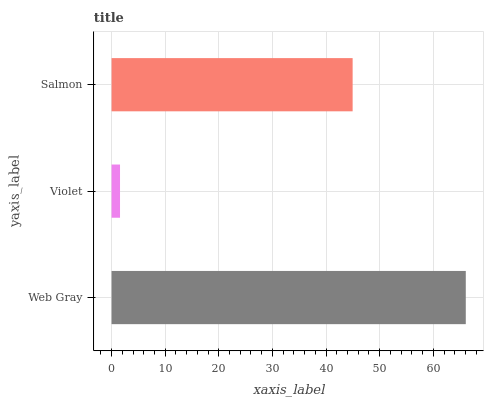Is Violet the minimum?
Answer yes or no. Yes. Is Web Gray the maximum?
Answer yes or no. Yes. Is Salmon the minimum?
Answer yes or no. No. Is Salmon the maximum?
Answer yes or no. No. Is Salmon greater than Violet?
Answer yes or no. Yes. Is Violet less than Salmon?
Answer yes or no. Yes. Is Violet greater than Salmon?
Answer yes or no. No. Is Salmon less than Violet?
Answer yes or no. No. Is Salmon the high median?
Answer yes or no. Yes. Is Salmon the low median?
Answer yes or no. Yes. Is Web Gray the high median?
Answer yes or no. No. Is Violet the low median?
Answer yes or no. No. 